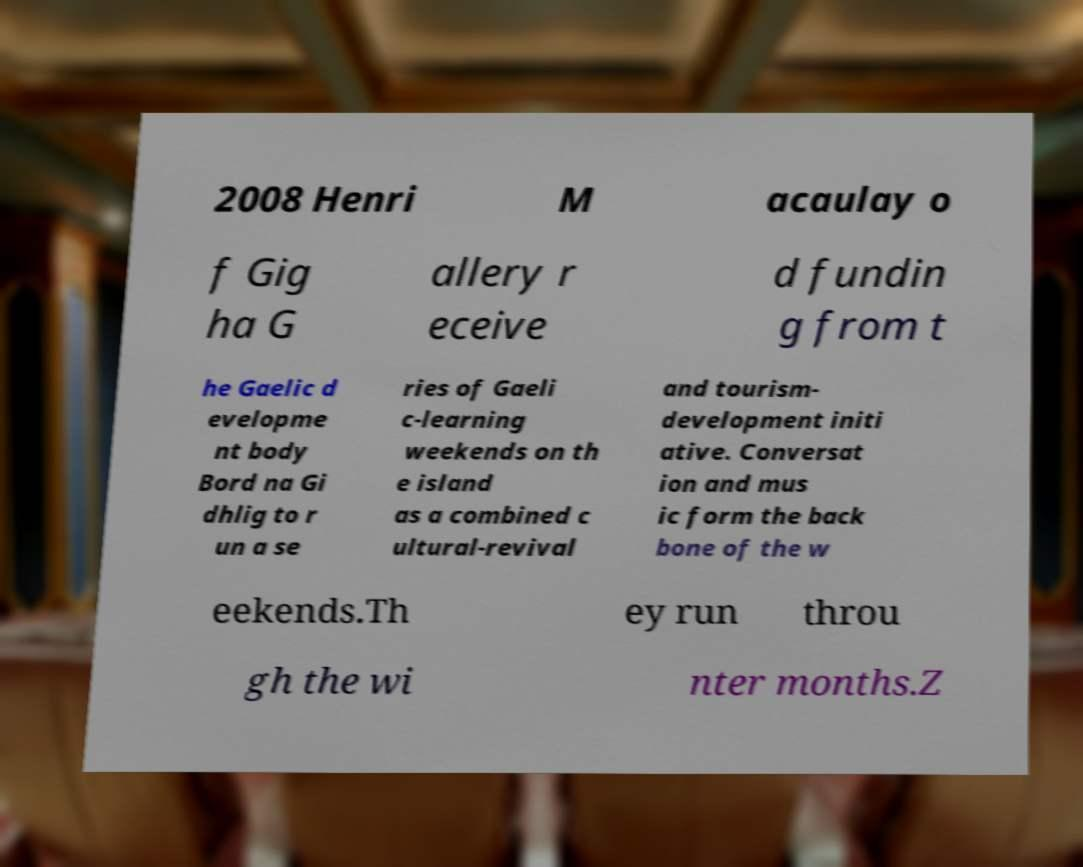Can you accurately transcribe the text from the provided image for me? 2008 Henri M acaulay o f Gig ha G allery r eceive d fundin g from t he Gaelic d evelopme nt body Bord na Gi dhlig to r un a se ries of Gaeli c-learning weekends on th e island as a combined c ultural-revival and tourism- development initi ative. Conversat ion and mus ic form the back bone of the w eekends.Th ey run throu gh the wi nter months.Z 